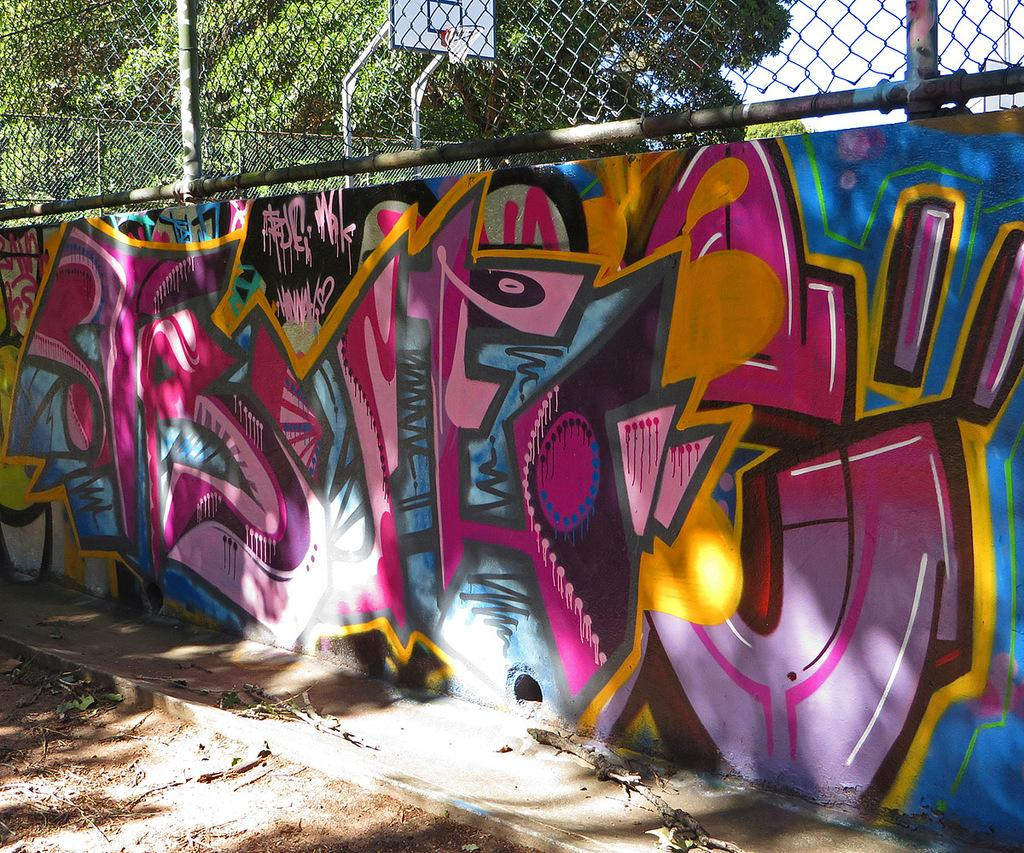What is displayed on the wall in the image? There is an art piece on the wall in the image. What type of structure can be seen in the image? There is a fencing in the image. What sports-related object is visible in the image? There is a basketball goal post in the image. What type of natural element is present at the top of the image? There is a tree at the top of the image. How many legs are visible on the art piece in the image? The art piece is on the wall, so it does not have legs. What shape is the basketball goal post in the image? The shape of the basketball goal post is not mentioned in the facts, so we cannot determine its shape from the image. 